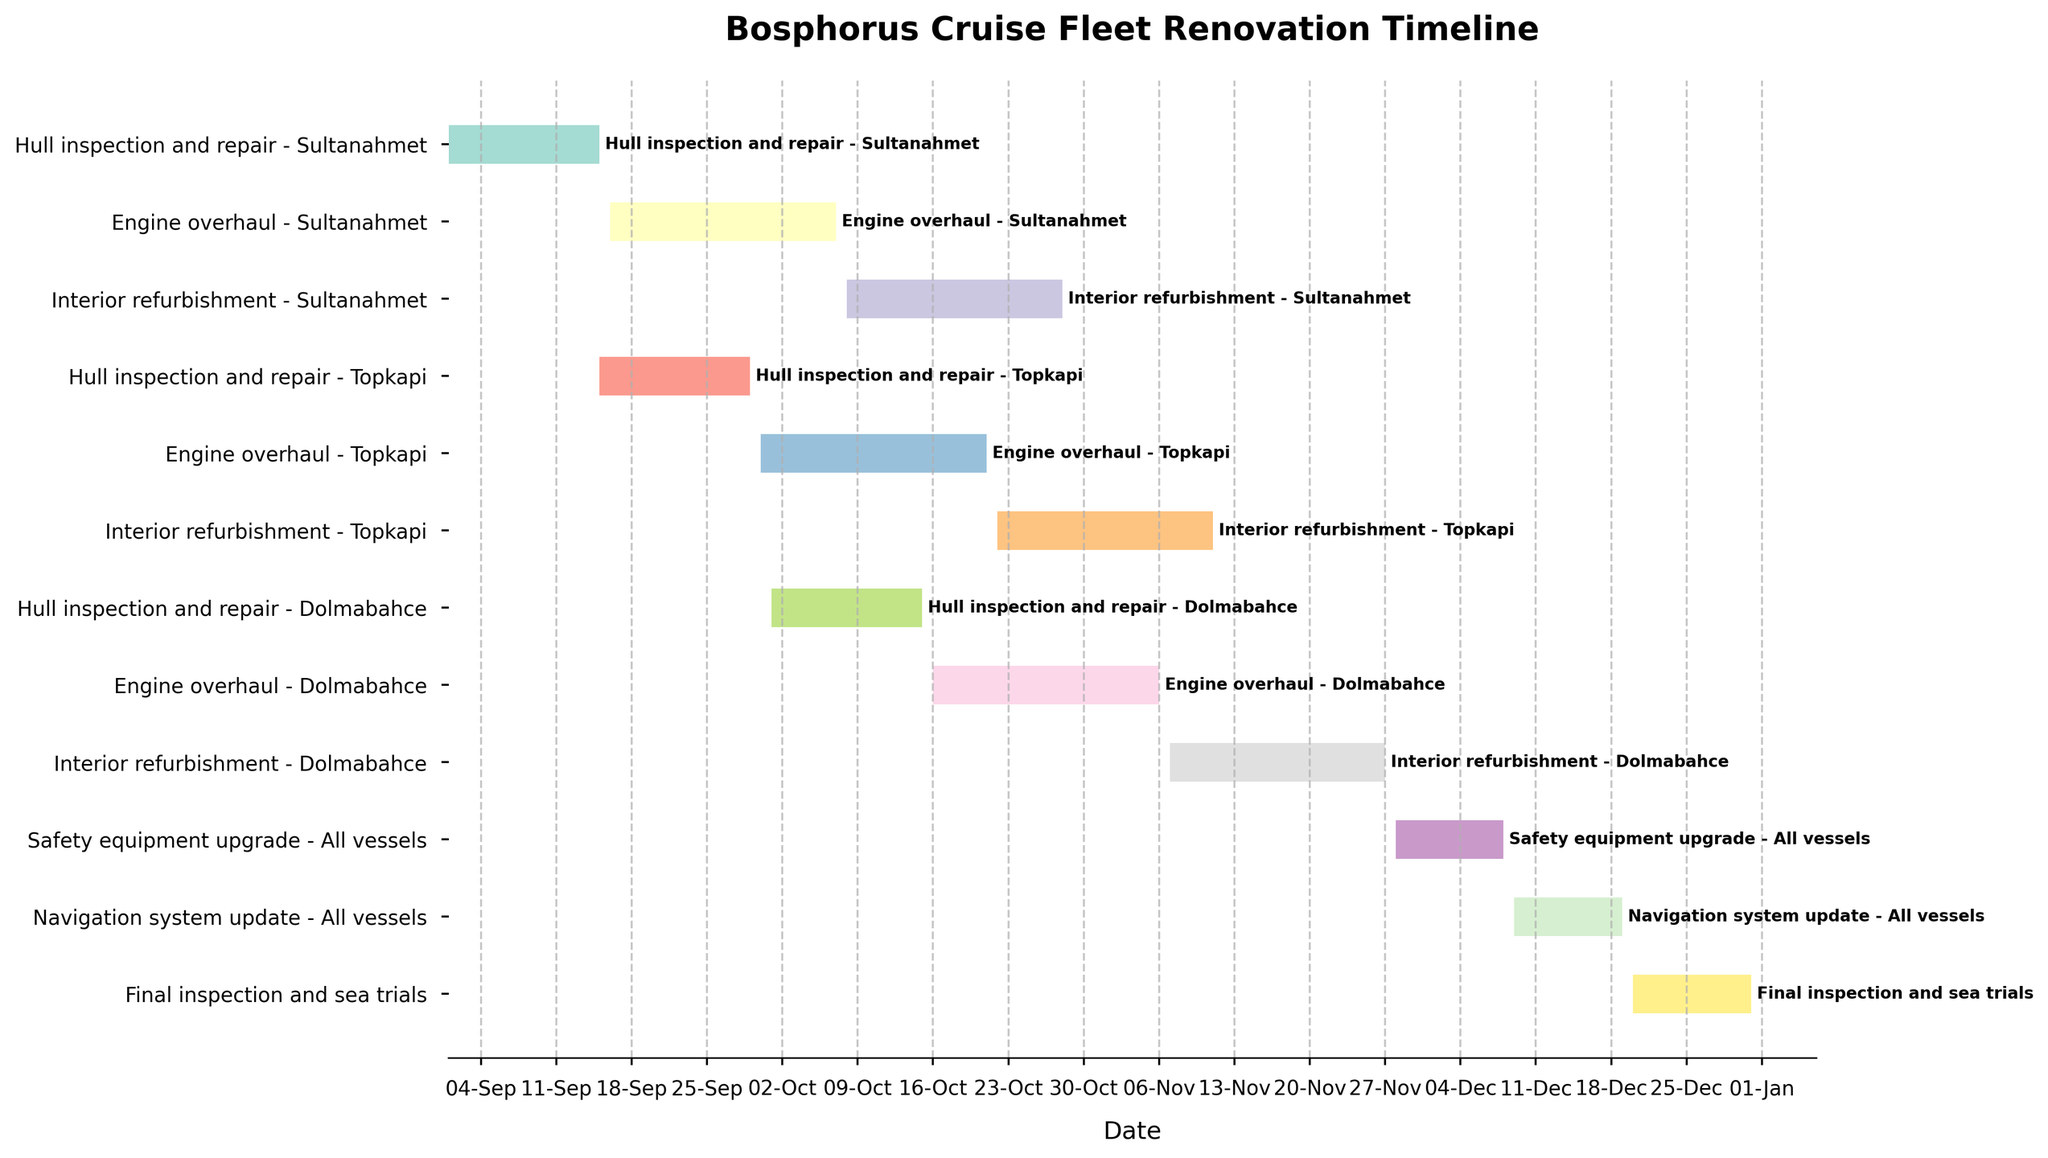What is the title of the Gantt Chart? The title of the chart is usually displayed at the top. It states the main focus or summary of the chart.
Answer: Bosphorus Cruise Fleet Renovation Timeline How many stages are included in the renovation timeline for Sultanahmet? Sultanahmet has three stages in its renovation timeline. These can be identified by looking at the start date, end date, and stage descriptions.
Answer: Three stages When does the Engine overhaul for Topkapi begin and end? The dates for the Engine overhaul of Topkapi can be found by locating the corresponding task and reading its start and end dates on the timeline.
Answer: Begins on September 30 and ends on October 21 Which task has the shortest duration? By examining the length of the bars on the horizontal axis, the task with the shortest duration can be identified.
Answer: Final inspection and sea trials Compare the timeline of the Engine overhaul for Sultanahmet and Dolmabahce. Which one takes longer? By looking at the length of the bars for the Engine overhauls of both Sultanahmet and Dolmabahce, we can compare their durations directly on the chart.
Answer: Dolmabahce How long is the total renovation period for Topkapi? The total renovation period for Topkapi can be calculated by summing the durations of Hull inspection and repair, Engine overhaul, and Interior refurbishment.
Answer: 58 days When does the Safety equipment upgrade for all vessels take place? The Safety equipment upgrade task can be identified on the chart, and its duration is read from the start to the end date on the horizontal axis.
Answer: From November 28 to December 08 Which vessel's hull repair starts first? By looking at the start dates for Hull inspection and repair tasks across all vessels, the vessel with the earliest start date is determined.
Answer: Sultanahmet What is the duration of the Interior refurbishment for Dolmabahce? The duration of the Interior refurbishment for Dolmabahce can be found by noting the start and end dates and calculating the difference.
Answer: 21 days Which tasks overlap with the Final inspection and sea trials? Tasks that overlap with the Final inspection and sea trials can be identified by checking tasks whose bars intersect with the Final inspection and sea trials bar on the timeline.
Answer: Navigation system update 